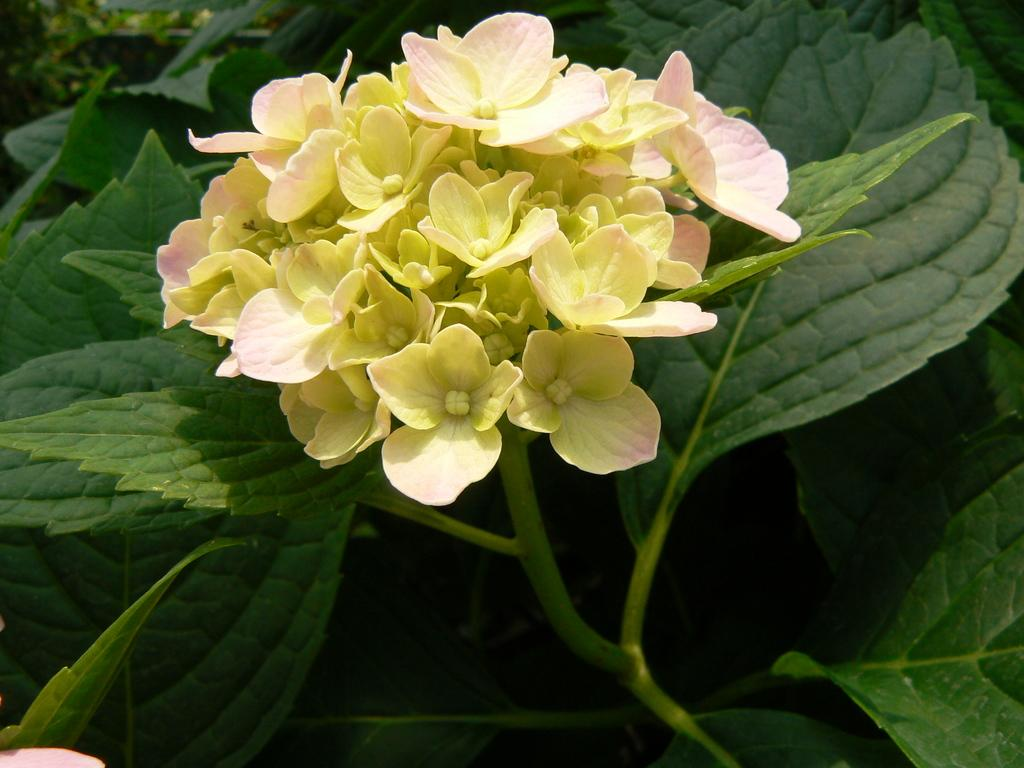What is the main subject of the image? The main subject of the image is a bunch of small flowers. What can be seen surrounding the flowers? There are green leaves surrounding the flowers. What type of insurance policy is being discussed in the image? There is no mention of insurance in the image; it features a bunch of small flowers surrounded by green leaves. 